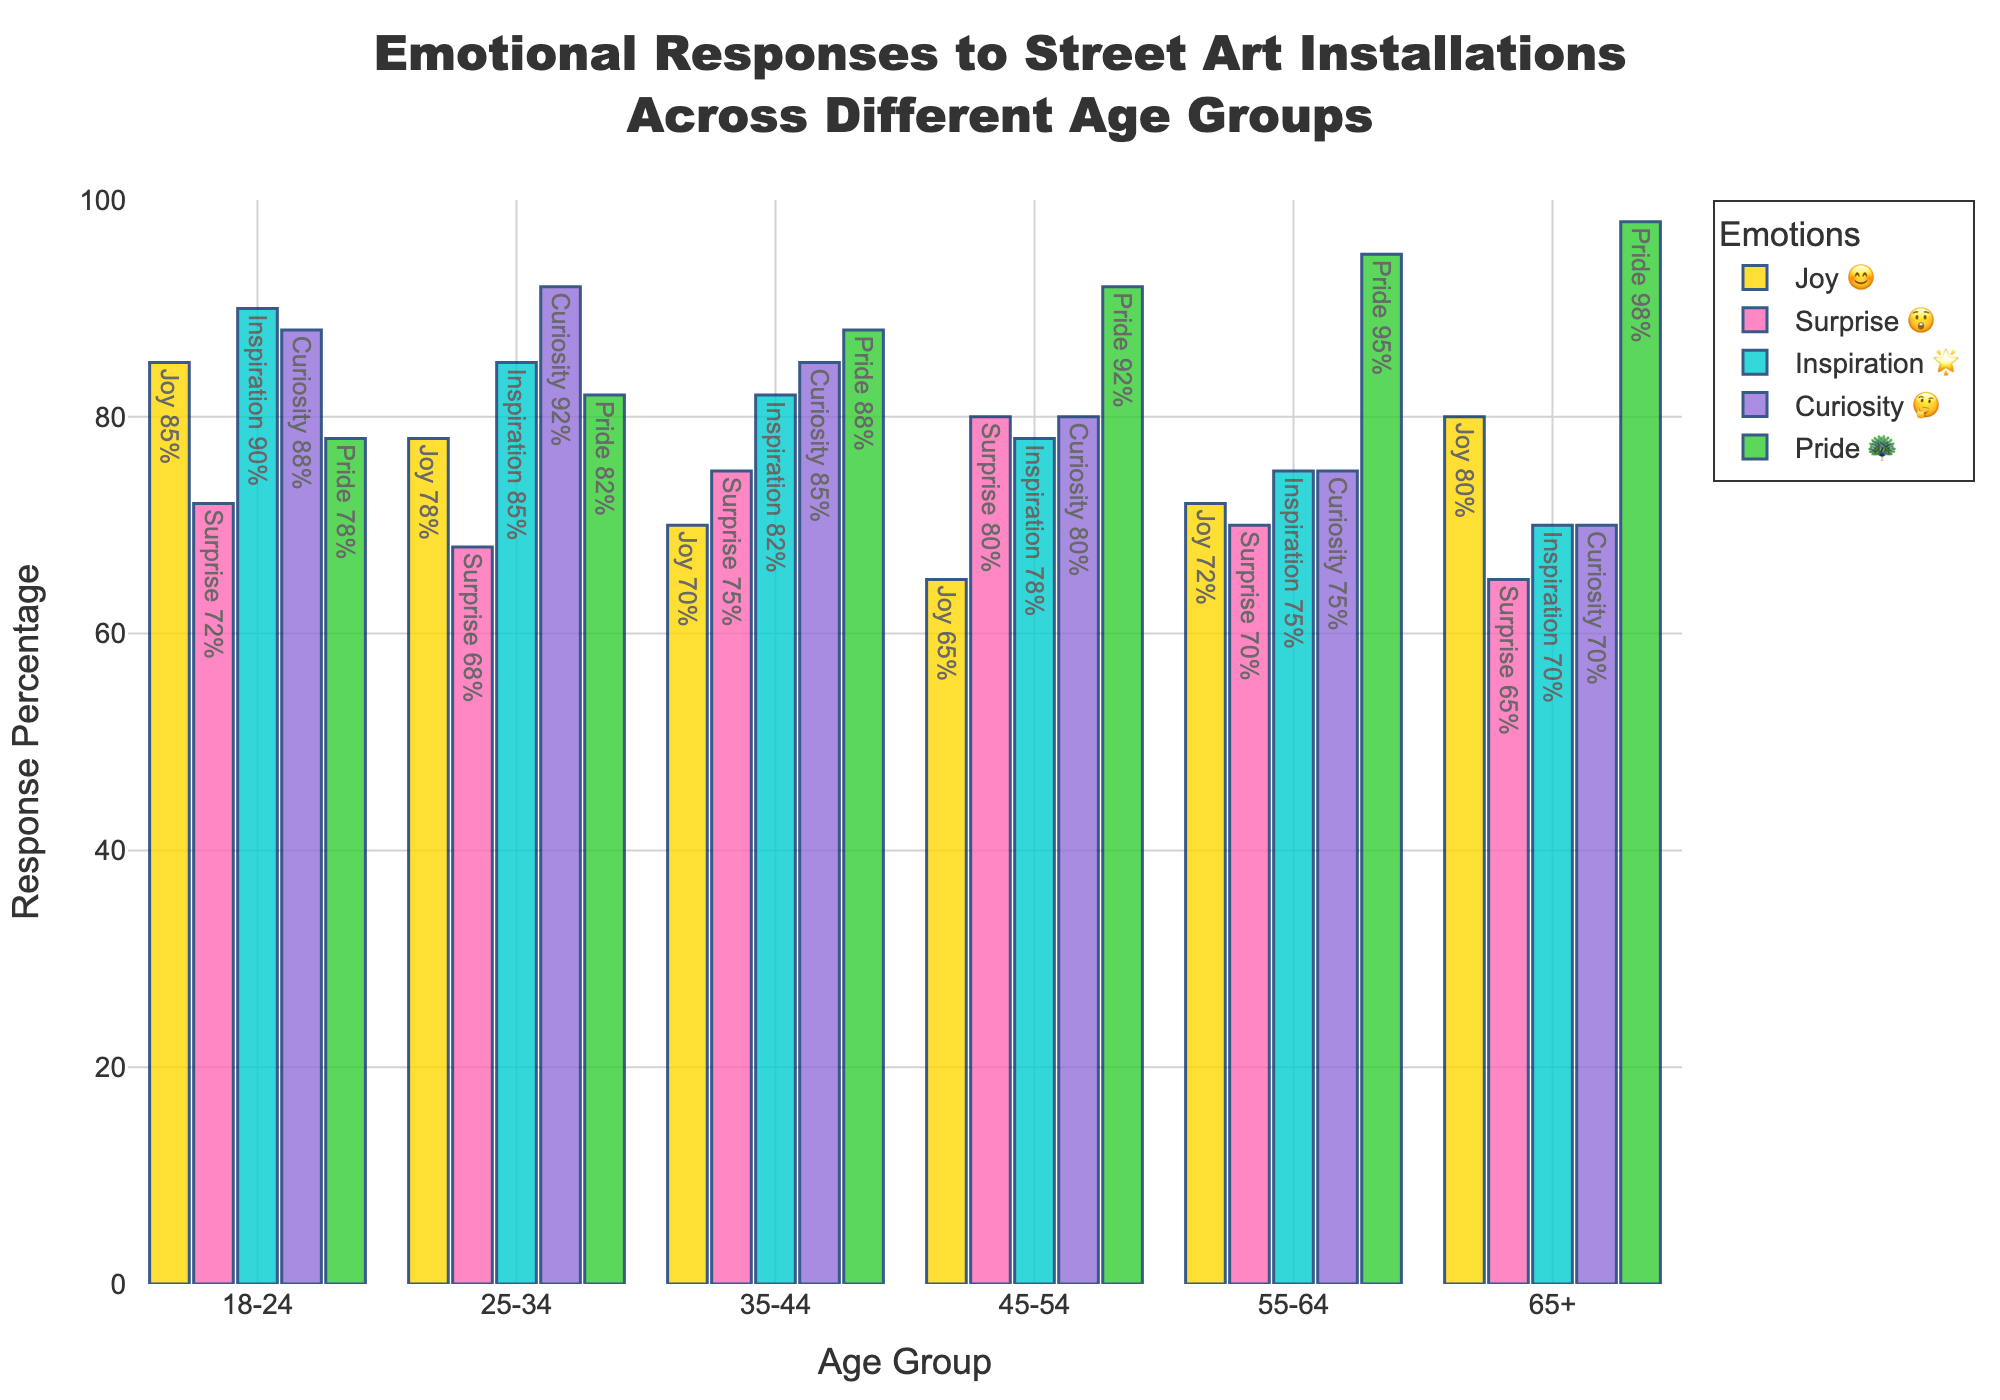What emotion has the highest response percentage among 18-24 age group? According to the chart, within the 18-24 age group, the highest percentage is for "Inspiration 🌟" at 90%.
Answer: Inspiration 🌟 Which age group has the highest Curiosity 🤔 response? The chart shows Curiosity 🤔 percentages for each age group: 18-24 (88%), 25-34 (92%), 35-44 (85%), 45-54 (80%), 55-64 (75%), 65+ (70%). The 25-34 age group has the highest at 92%.
Answer: 25-34 Compare Joy 😊 percentages between the age groups 18-24 and 65+ The percentage for Joy 😊 in 18-24 is 85%, while for 65+ it is 80%. 18-24 has a higher percentage of Joy 😊 by 5%.
Answer: 18-24 What is the average percentage of Pride 🦚 across all age groups? Pride 🦚 percentages are 78, 82, 88, 92, 95, and 98. Summing these yields 533, and dividing by six gives an average of 88.8.
Answer: 88.8 Which emotional response has the lowest percentage for the 25-34 age group? For the 25-34 age group, the percentages are Joy 😊 (78), Surprise 😲 (68), Inspiration 🌟 (85), Curiosity 🤔 (92), Pride 🦚 (82). The lowest is Surprise 😲 at 68%.
Answer: Surprise 😲 Is there any age group where Surprise 😲 has the highest percentage compared to other emotions? By comparing percentages by age group, the 45-54 age group has the highest Surprise 😲 at 80%, which is higher than any other emotional response in that group.
Answer: 45-54 What is the sum of the Joy 😊 responses for age groups 35-44 and 55-64? The chart shows Joy 😊 percentages for 35-44 (70) and 55-64 (72). Summing them gives 142.
Answer: 142 Which age group has the most even spread of emotions? By examining the data, the 65+ group shows the most even distribution with values quite close: Joy 😊 (80), Surprise 😲 (65), Inspiration 🌟 (70), Curiosity 🤔 (70), Pride 🦚 (98).
Answer: 65+ How does the response for Inspiration 🌟 change from younger (18-24) to older (65+) age groups? For Inspiration 🌟, the chart shows: 18-24 (90), 25-34 (85), 35-44 (82), 45-54 (78), 55-64 (75), 65+ (70). The percentage gradually decreases with increasing age.
Answer: Decreases 